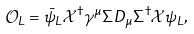Convert formula to latex. <formula><loc_0><loc_0><loc_500><loc_500>\mathcal { O } _ { L } = \bar { \psi } _ { L } \mathcal { X } ^ { \dagger } \gamma ^ { \mu } \Sigma D _ { \mu } \Sigma ^ { \dagger } \mathcal { X } \psi _ { L } ,</formula> 